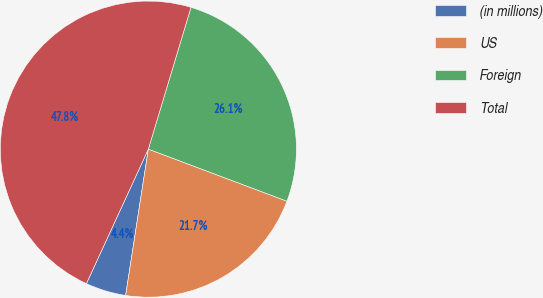Convert chart. <chart><loc_0><loc_0><loc_500><loc_500><pie_chart><fcel>(in millions)<fcel>US<fcel>Foreign<fcel>Total<nl><fcel>4.42%<fcel>21.73%<fcel>26.07%<fcel>47.78%<nl></chart> 